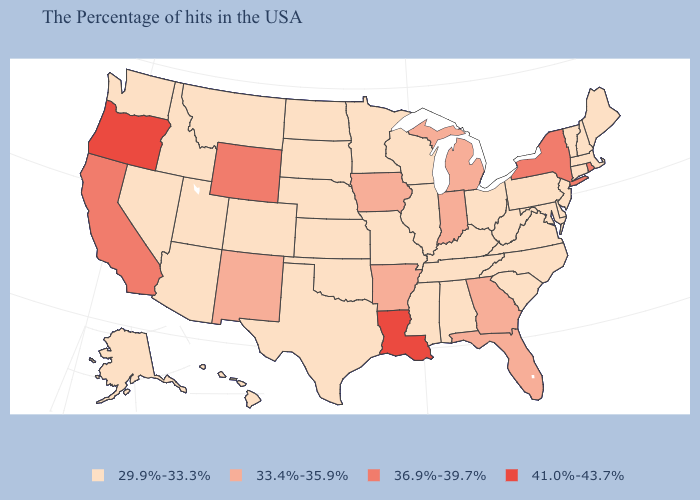Name the states that have a value in the range 41.0%-43.7%?
Be succinct. Louisiana, Oregon. Name the states that have a value in the range 41.0%-43.7%?
Give a very brief answer. Louisiana, Oregon. Which states have the lowest value in the USA?
Quick response, please. Maine, Massachusetts, New Hampshire, Vermont, Connecticut, New Jersey, Delaware, Maryland, Pennsylvania, Virginia, North Carolina, South Carolina, West Virginia, Ohio, Kentucky, Alabama, Tennessee, Wisconsin, Illinois, Mississippi, Missouri, Minnesota, Kansas, Nebraska, Oklahoma, Texas, South Dakota, North Dakota, Colorado, Utah, Montana, Arizona, Idaho, Nevada, Washington, Alaska, Hawaii. Name the states that have a value in the range 36.9%-39.7%?
Give a very brief answer. Rhode Island, New York, Wyoming, California. How many symbols are there in the legend?
Quick response, please. 4. Does West Virginia have a higher value than New Jersey?
Be succinct. No. Does Massachusetts have the lowest value in the Northeast?
Quick response, please. Yes. Does Minnesota have the lowest value in the MidWest?
Be succinct. Yes. Does Ohio have the same value as Delaware?
Quick response, please. Yes. Does Indiana have a lower value than Arkansas?
Be succinct. No. Does Connecticut have the lowest value in the USA?
Be succinct. Yes. Name the states that have a value in the range 36.9%-39.7%?
Answer briefly. Rhode Island, New York, Wyoming, California. Name the states that have a value in the range 36.9%-39.7%?
Be succinct. Rhode Island, New York, Wyoming, California. What is the value of Massachusetts?
Be succinct. 29.9%-33.3%. 